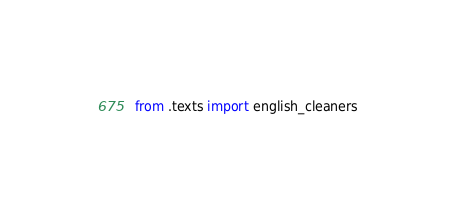Convert code to text. <code><loc_0><loc_0><loc_500><loc_500><_Python_>from .texts import english_cleaners
</code> 